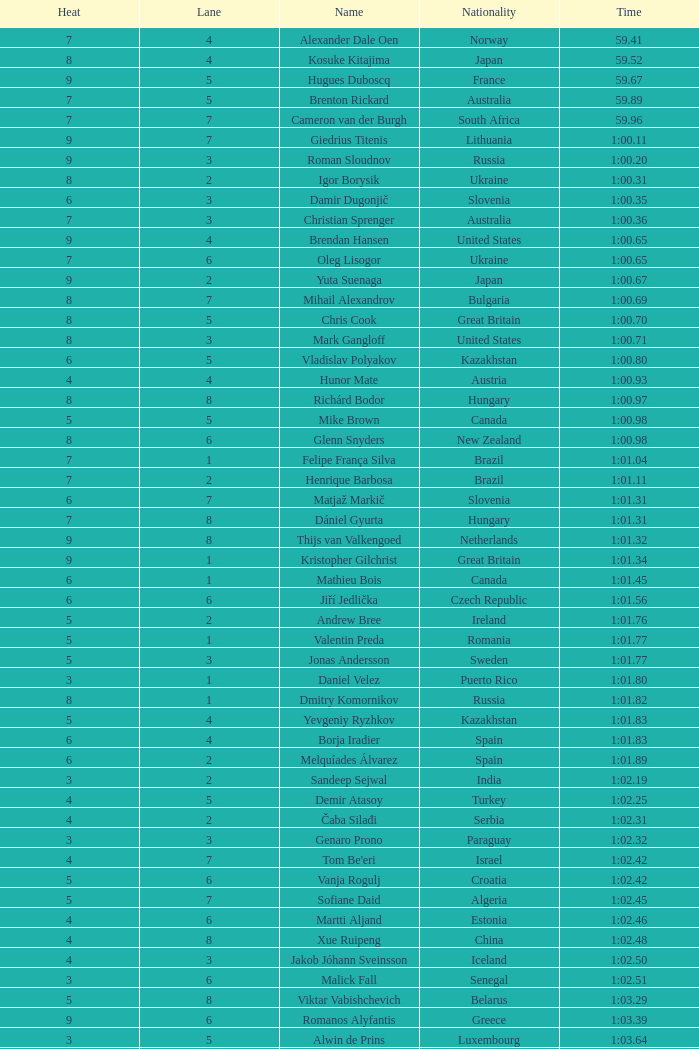What is the time for vietnam in lane 5 when the heat is less than 5? 1:06.36. 